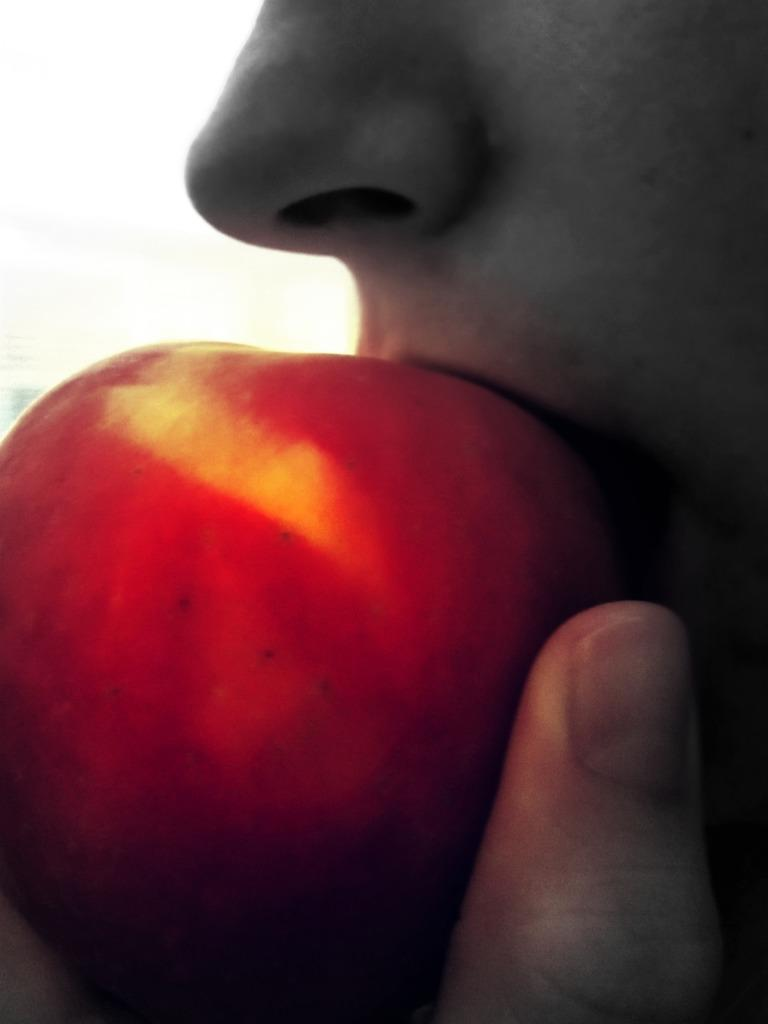What is happening in the image? There is a person in the image, and they are eating an apple. Can you describe the person's action in more detail? The person is biting into the apple, which suggests they are eating it. What type of watch is the person wearing in the image? There is no watch visible in the image; the person is eating an apple. Can you describe the key that the person is holding in the image? There is no key present in the image; the person is eating an apple. 